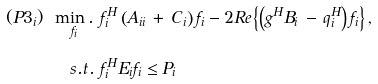Convert formula to latex. <formula><loc_0><loc_0><loc_500><loc_500>( P 3 _ { i } ) \ \underset { f _ { i } } { \min . } & \ f _ { i } ^ { H } \left ( A _ { i i } \, + \, C _ { i } \right ) f _ { i } - 2 R e \left \{ \left ( g ^ { H } B _ { i } \, - \, q _ { i } ^ { H } \right ) f _ { i } \right \} , \\ s . t . & \ f _ { i } ^ { H } E _ { i } f _ { i } \leq P _ { i }</formula> 